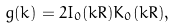Convert formula to latex. <formula><loc_0><loc_0><loc_500><loc_500>g ( k ) = 2 I _ { 0 } ( k R ) K _ { 0 } ( k R ) ,</formula> 